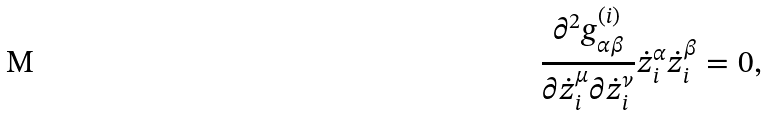<formula> <loc_0><loc_0><loc_500><loc_500>\frac { \partial ^ { 2 } g ^ { ( i ) } _ { \alpha \beta } } { \partial \dot { z } _ { i } ^ { \mu } \partial \dot { z } _ { i } ^ { \nu } } \dot { z } _ { i } ^ { \alpha } \dot { z } _ { i } ^ { \beta } = 0 ,</formula> 